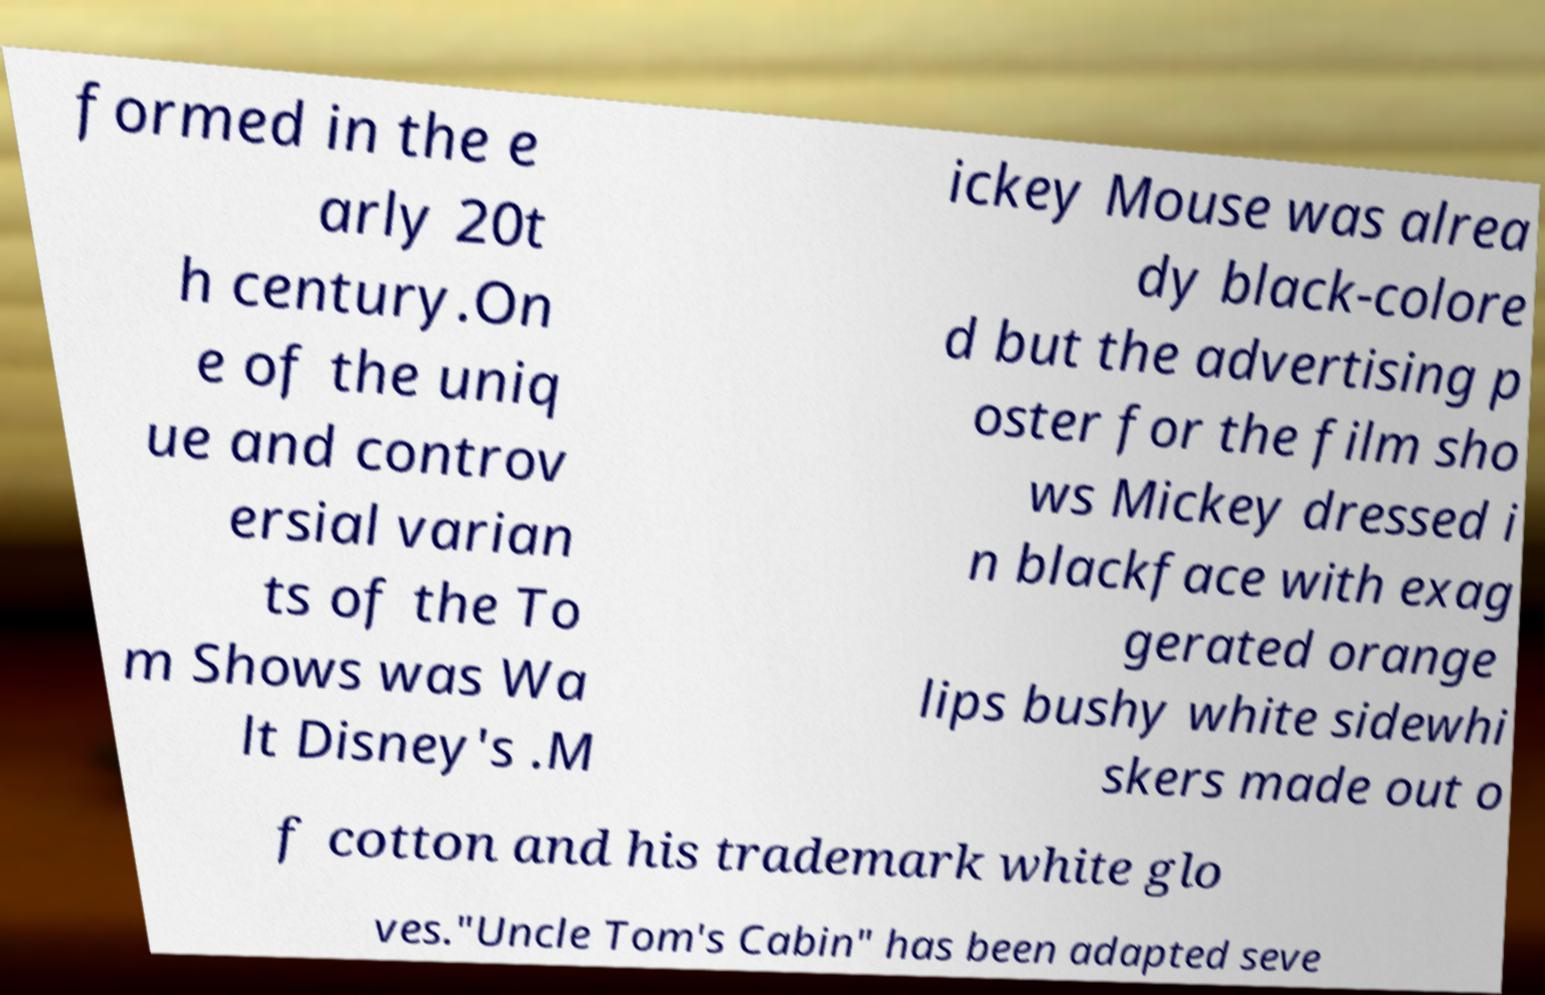For documentation purposes, I need the text within this image transcribed. Could you provide that? formed in the e arly 20t h century.On e of the uniq ue and controv ersial varian ts of the To m Shows was Wa lt Disney's .M ickey Mouse was alrea dy black-colore d but the advertising p oster for the film sho ws Mickey dressed i n blackface with exag gerated orange lips bushy white sidewhi skers made out o f cotton and his trademark white glo ves."Uncle Tom's Cabin" has been adapted seve 